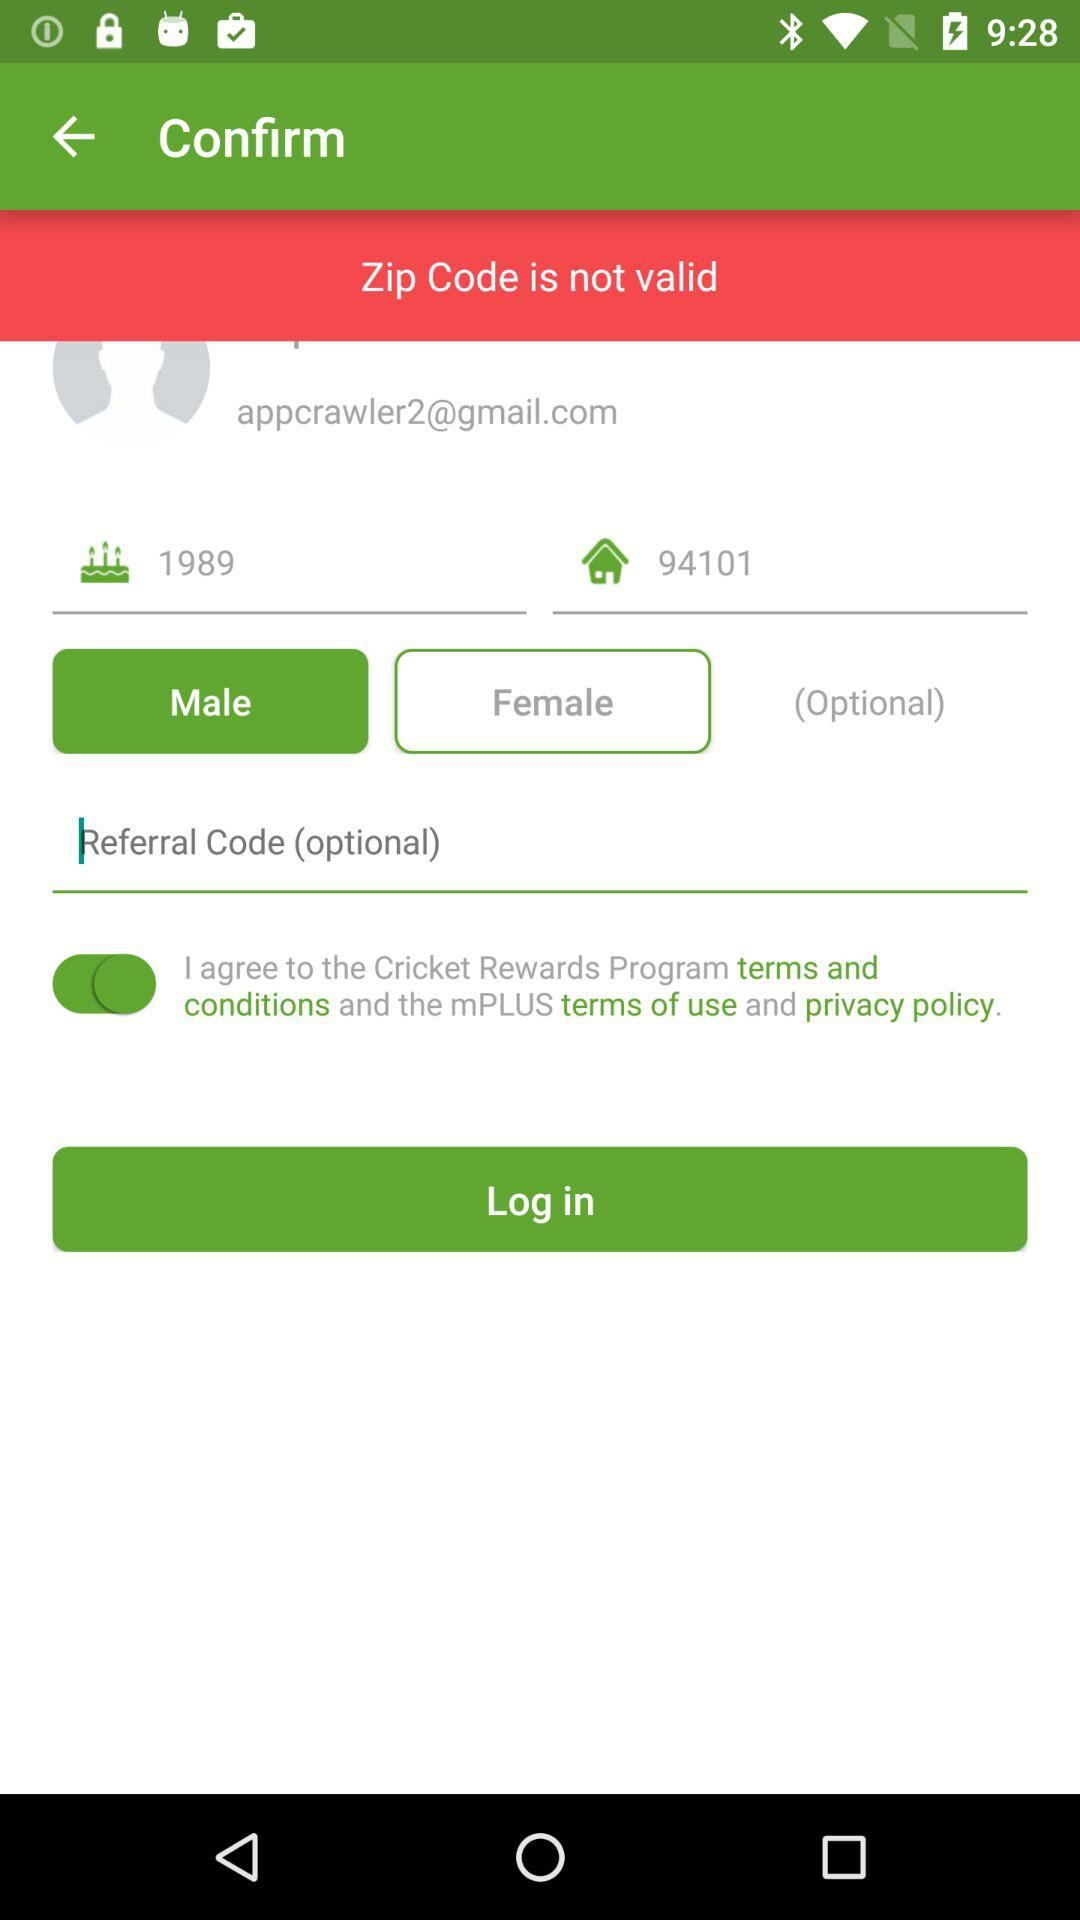What is the gender selected? The selected gender is male. 